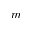<formula> <loc_0><loc_0><loc_500><loc_500>m</formula> 